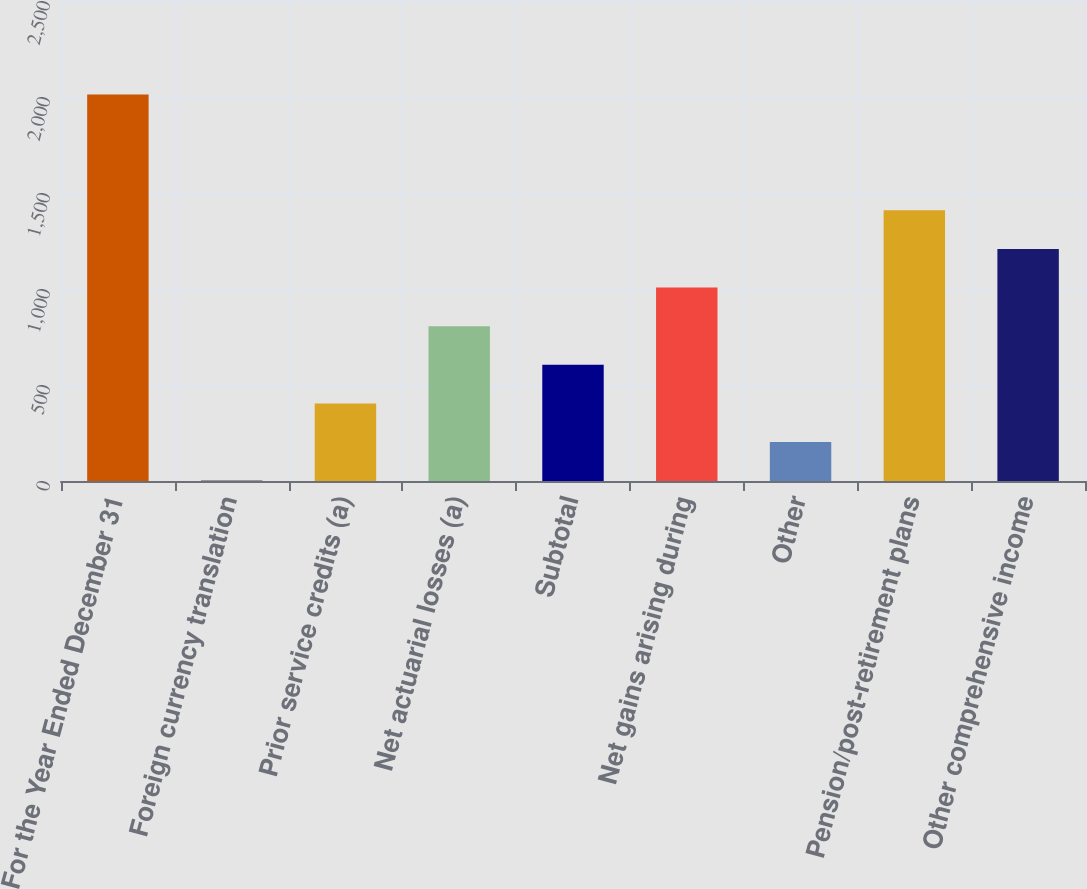Convert chart. <chart><loc_0><loc_0><loc_500><loc_500><bar_chart><fcel>For the Year Ended December 31<fcel>Foreign currency translation<fcel>Prior service credits (a)<fcel>Net actuarial losses (a)<fcel>Subtotal<fcel>Net gains arising during<fcel>Other<fcel>Pension/post-retirement plans<fcel>Other comprehensive income<nl><fcel>2013<fcel>2<fcel>404.2<fcel>806.4<fcel>605.3<fcel>1007.5<fcel>203.1<fcel>1409.7<fcel>1208.6<nl></chart> 